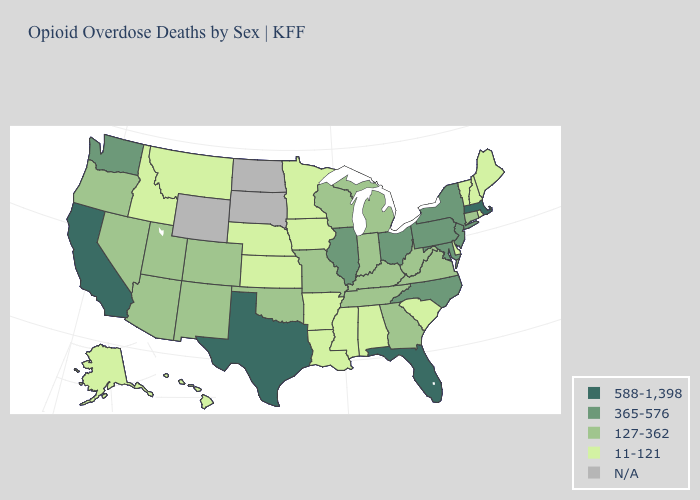Does Ohio have the highest value in the MidWest?
Keep it brief. Yes. What is the value of Vermont?
Answer briefly. 11-121. Does Texas have the highest value in the South?
Write a very short answer. Yes. What is the highest value in the Northeast ?
Answer briefly. 588-1,398. What is the lowest value in the USA?
Short answer required. 11-121. What is the value of Wisconsin?
Keep it brief. 127-362. What is the value of Vermont?
Give a very brief answer. 11-121. What is the value of South Carolina?
Answer briefly. 11-121. Among the states that border Michigan , which have the highest value?
Be succinct. Ohio. What is the lowest value in states that border Connecticut?
Write a very short answer. 11-121. What is the highest value in the West ?
Short answer required. 588-1,398. Name the states that have a value in the range 365-576?
Be succinct. Illinois, Maryland, New Jersey, New York, North Carolina, Ohio, Pennsylvania, Washington. What is the highest value in the West ?
Short answer required. 588-1,398. What is the value of Connecticut?
Concise answer only. 127-362. What is the value of Texas?
Write a very short answer. 588-1,398. 